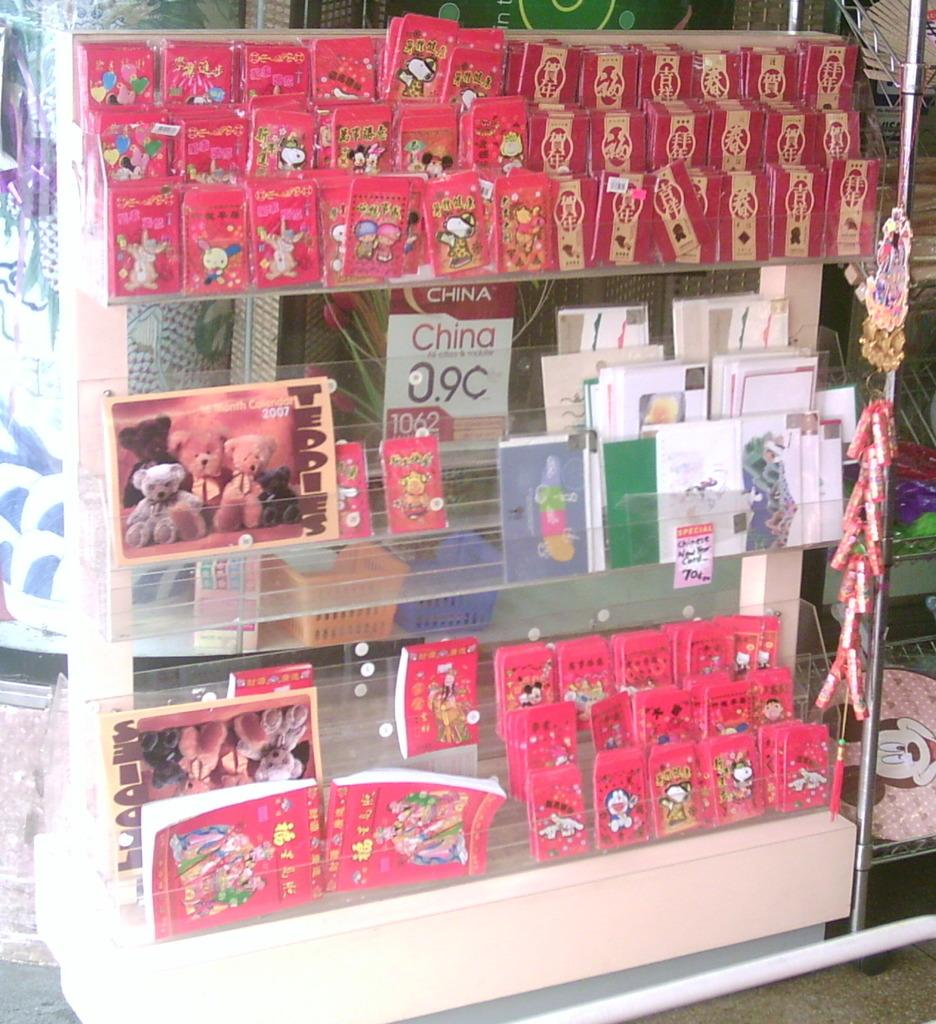What objects can be seen in the image? There are cards and books in the image. Where are the cards and books located? The cards and books are placed on a shelf. What type of carriage is being discussed by the cards and books in the image? There is no carriage or discussion present in the image; it only features cards and books placed on a shelf. 